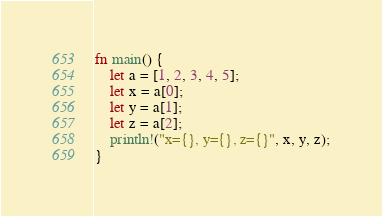Convert code to text. <code><loc_0><loc_0><loc_500><loc_500><_Rust_>fn main() {
    let a = [1, 2, 3, 4, 5];
    let x = a[0];
    let y = a[1];
    let z = a[2];
    println!("x={}, y={}, z={}", x, y, z);
}
</code> 